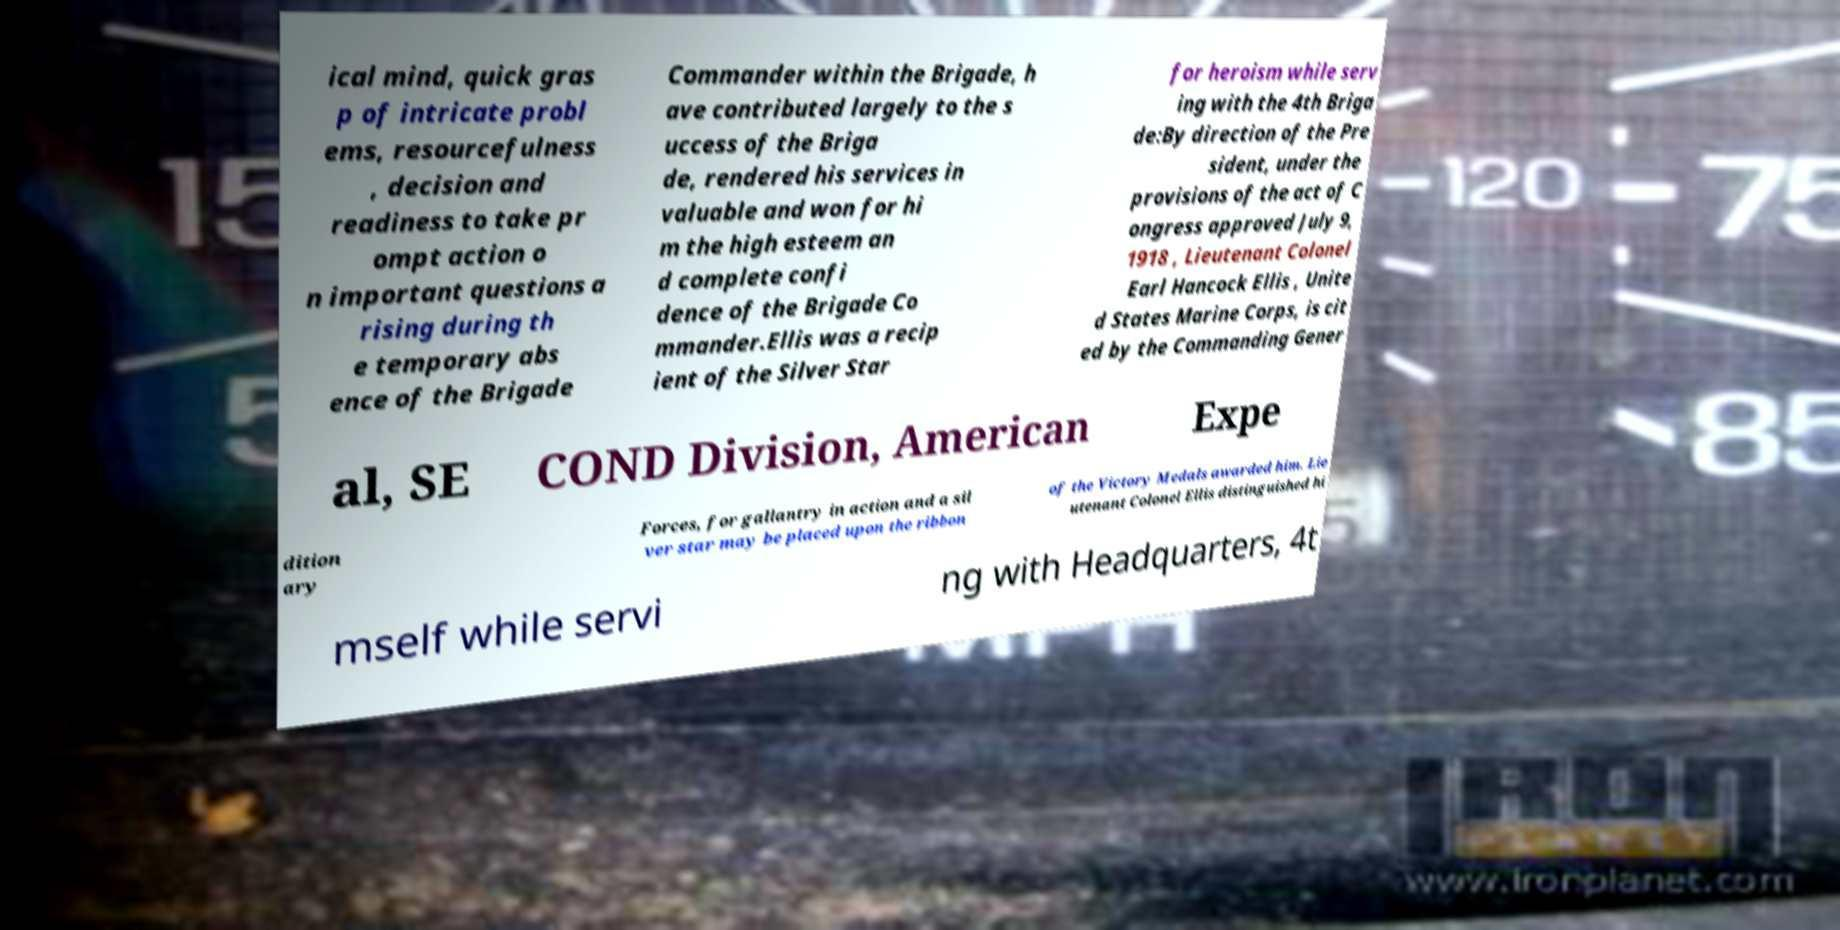Please identify and transcribe the text found in this image. ical mind, quick gras p of intricate probl ems, resourcefulness , decision and readiness to take pr ompt action o n important questions a rising during th e temporary abs ence of the Brigade Commander within the Brigade, h ave contributed largely to the s uccess of the Briga de, rendered his services in valuable and won for hi m the high esteem an d complete confi dence of the Brigade Co mmander.Ellis was a recip ient of the Silver Star for heroism while serv ing with the 4th Briga de:By direction of the Pre sident, under the provisions of the act of C ongress approved July 9, 1918 , Lieutenant Colonel Earl Hancock Ellis , Unite d States Marine Corps, is cit ed by the Commanding Gener al, SE COND Division, American Expe dition ary Forces, for gallantry in action and a sil ver star may be placed upon the ribbon of the Victory Medals awarded him. Lie utenant Colonel Ellis distinguished hi mself while servi ng with Headquarters, 4t 